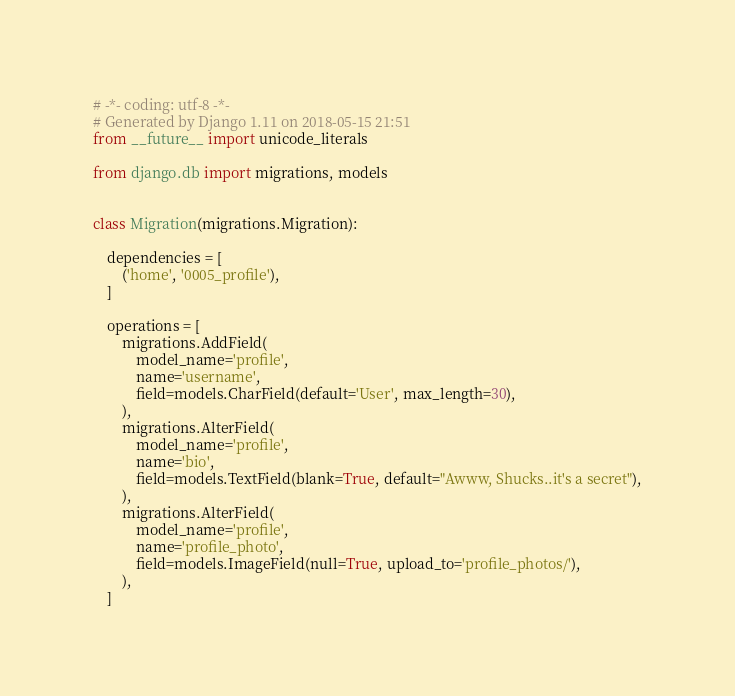<code> <loc_0><loc_0><loc_500><loc_500><_Python_># -*- coding: utf-8 -*-
# Generated by Django 1.11 on 2018-05-15 21:51
from __future__ import unicode_literals

from django.db import migrations, models


class Migration(migrations.Migration):

    dependencies = [
        ('home', '0005_profile'),
    ]

    operations = [
        migrations.AddField(
            model_name='profile',
            name='username',
            field=models.CharField(default='User', max_length=30),
        ),
        migrations.AlterField(
            model_name='profile',
            name='bio',
            field=models.TextField(blank=True, default="Awww, Shucks..it's a secret"),
        ),
        migrations.AlterField(
            model_name='profile',
            name='profile_photo',
            field=models.ImageField(null=True, upload_to='profile_photos/'),
        ),
    ]
</code> 